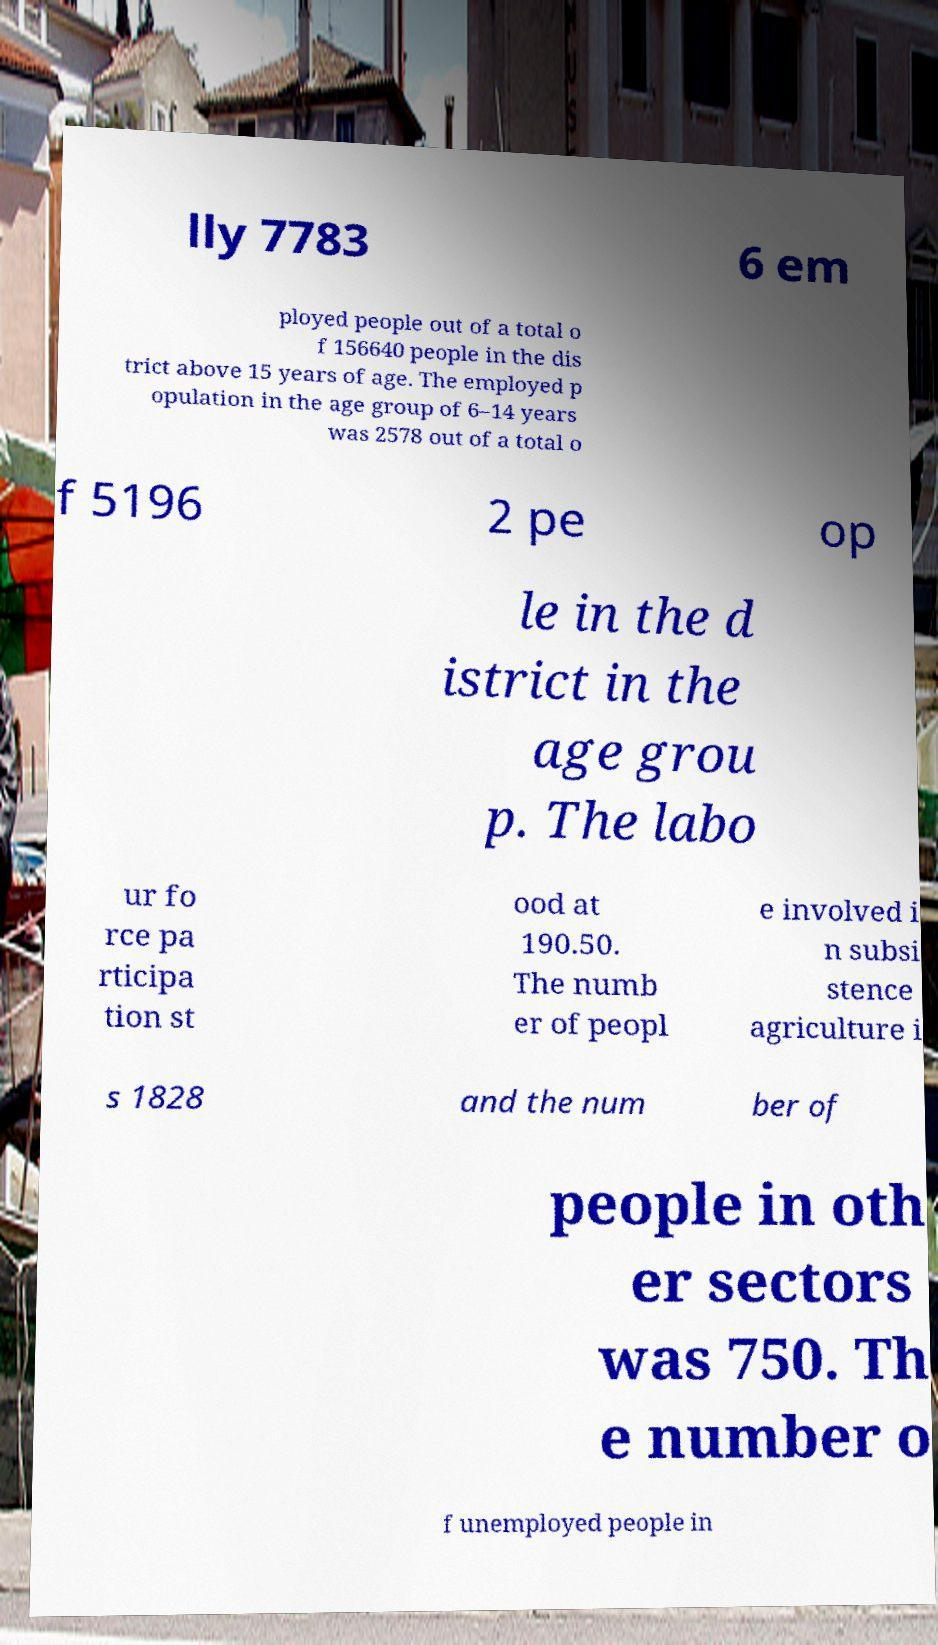Can you accurately transcribe the text from the provided image for me? lly 7783 6 em ployed people out of a total o f 156640 people in the dis trict above 15 years of age. The employed p opulation in the age group of 6–14 years was 2578 out of a total o f 5196 2 pe op le in the d istrict in the age grou p. The labo ur fo rce pa rticipa tion st ood at 190.50. The numb er of peopl e involved i n subsi stence agriculture i s 1828 and the num ber of people in oth er sectors was 750. Th e number o f unemployed people in 